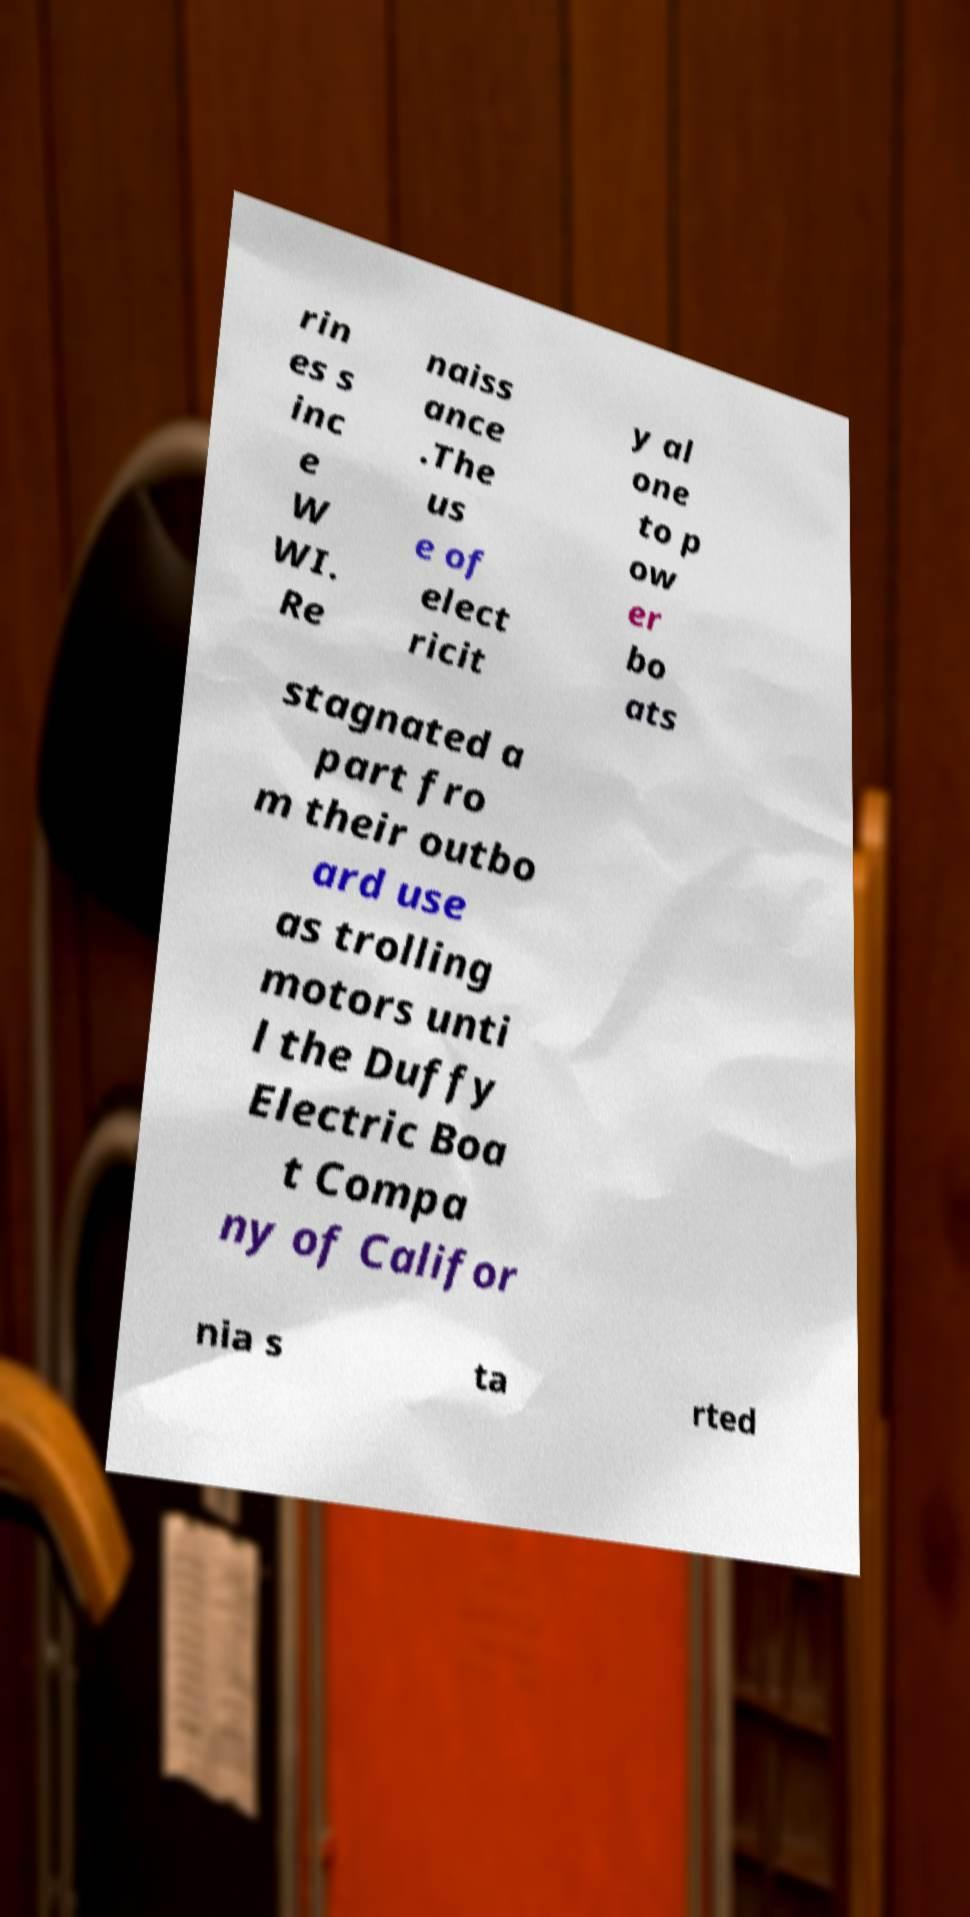Can you read and provide the text displayed in the image?This photo seems to have some interesting text. Can you extract and type it out for me? rin es s inc e W WI. Re naiss ance .The us e of elect ricit y al one to p ow er bo ats stagnated a part fro m their outbo ard use as trolling motors unti l the Duffy Electric Boa t Compa ny of Califor nia s ta rted 